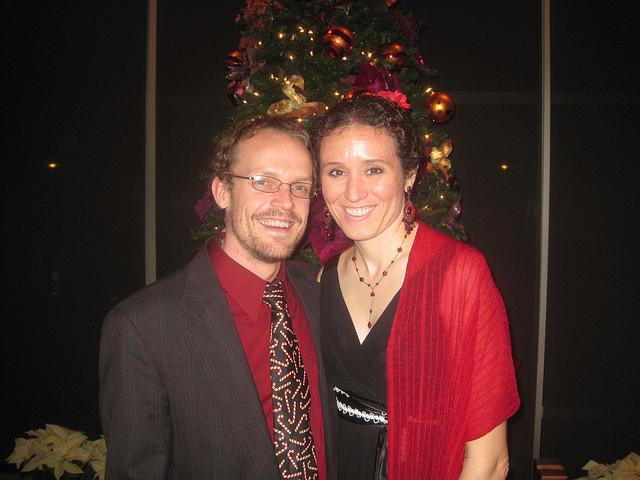What is pictured on the man's tie?
Keep it brief. Candy canes. What color is the man's tie?
Be succinct. Black. What color is the woman's scarf?
Write a very short answer. Red. Do both people have a strap going across their chests?
Answer briefly. No. Is this a modern photo?
Quick response, please. Yes. What color dominates her outfit?
Keep it brief. Red. What is the man wearing on his head?
Concise answer only. Nothing. How many strands are on the girls necklace?
Be succinct. 1. How many Christmas trees are in the background?
Keep it brief. 1. Who is taller in the scene?
Concise answer only. Woman. Does these people's clothes match?
Short answer required. Yes. What is the woman with the red coat holding in her left hand?
Give a very brief answer. Unknown. Are they wearing wigs?
Answer briefly. No. What color are their shirts?
Short answer required. Red. 